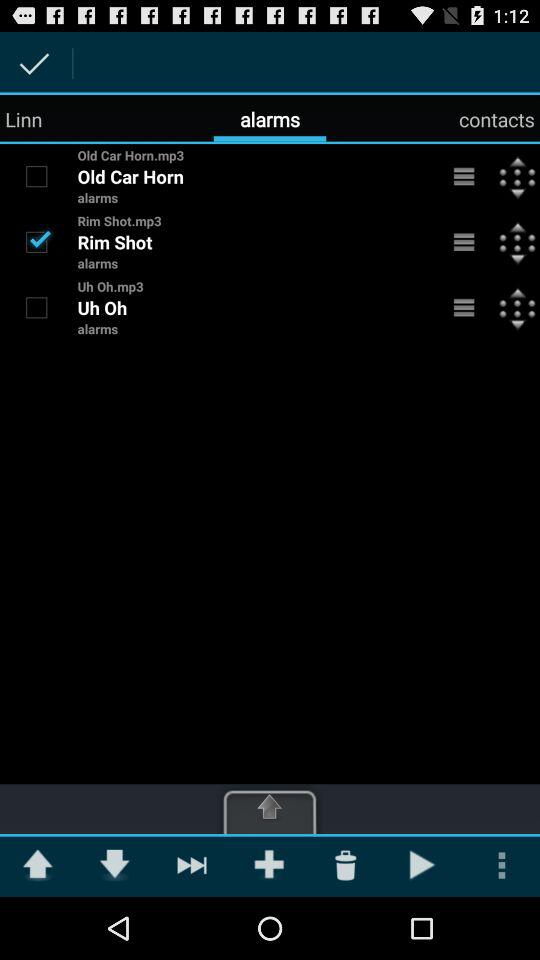Who is in the contacts?
When the provided information is insufficient, respond with <no answer>. <no answer> 